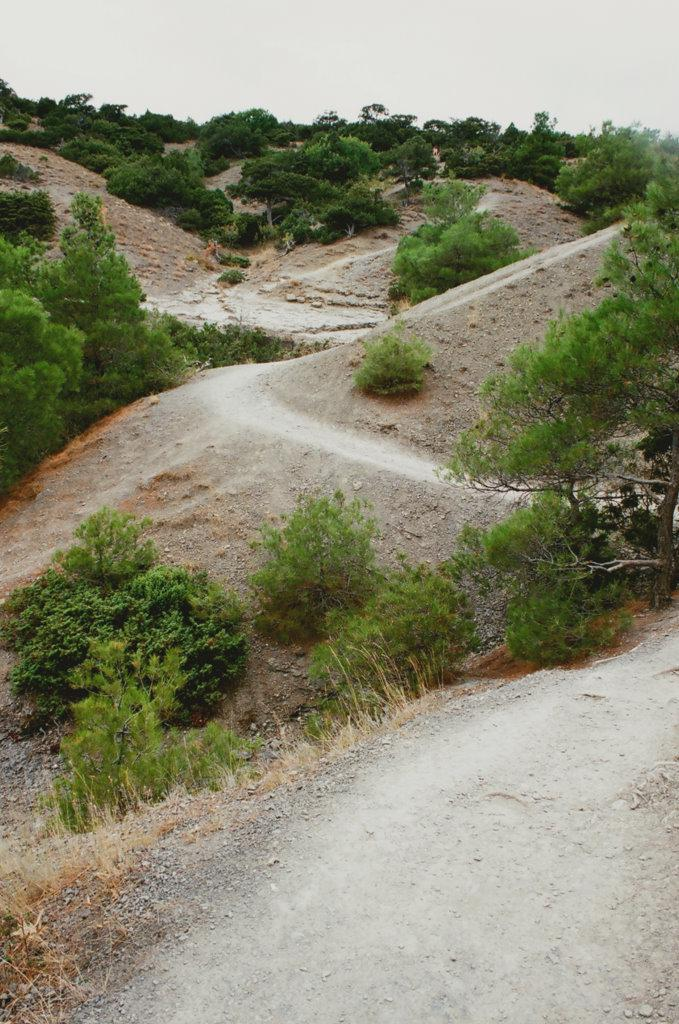What type of vegetation can be seen in the image? There are plants in the image. What is covering the ground in the image? There is grass on the ground in the image. What time of day is it in the image, and how does the body of water turn? There is no body of water present in the image, and the time of day cannot be determined from the image alone. 